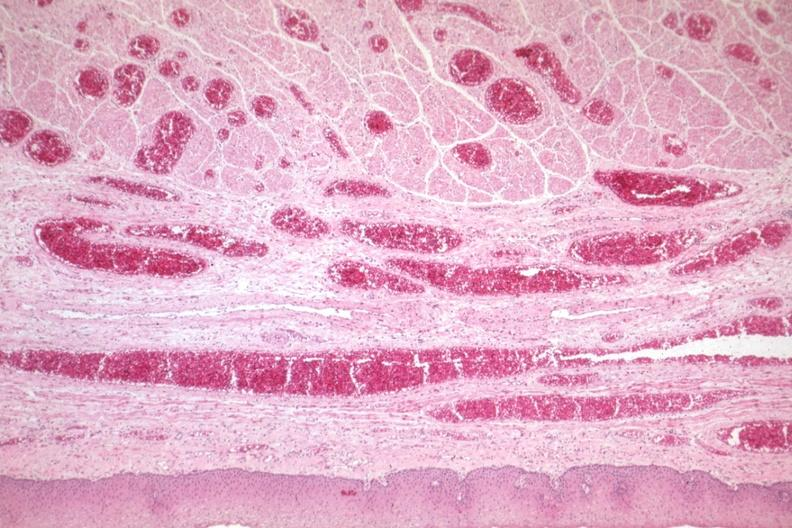what is present?
Answer the question using a single word or phrase. Gastrointestinal 